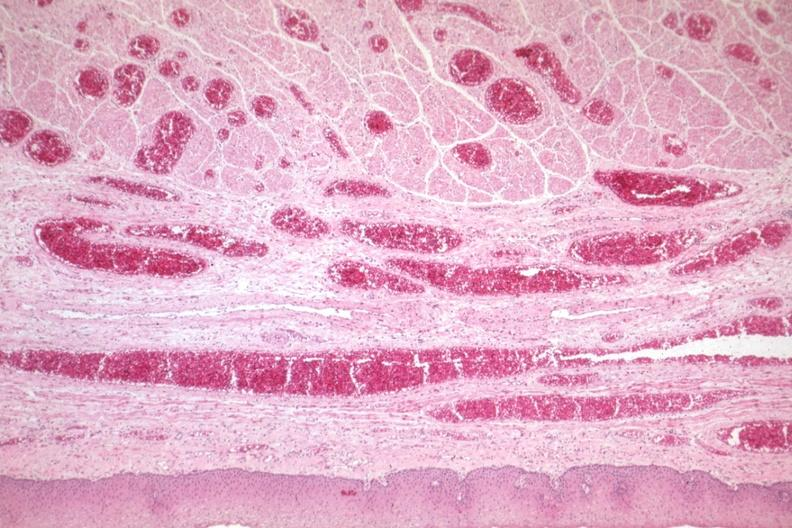what is present?
Answer the question using a single word or phrase. Gastrointestinal 